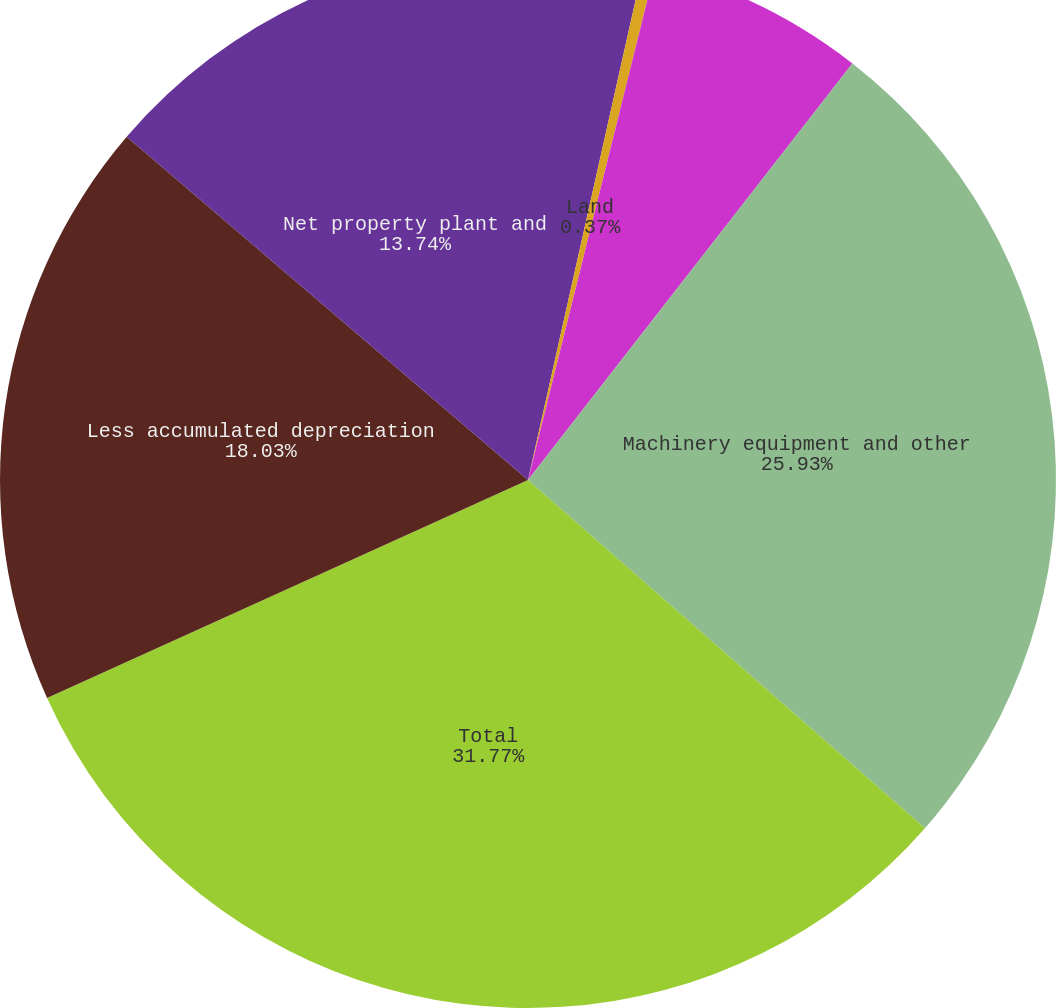Convert chart to OTSL. <chart><loc_0><loc_0><loc_500><loc_500><pie_chart><fcel>Millions of dollars<fcel>Land<fcel>Buildings and property<fcel>Machinery equipment and other<fcel>Total<fcel>Less accumulated depreciation<fcel>Net property plant and<nl><fcel>3.51%<fcel>0.37%<fcel>6.65%<fcel>25.93%<fcel>31.77%<fcel>18.03%<fcel>13.74%<nl></chart> 